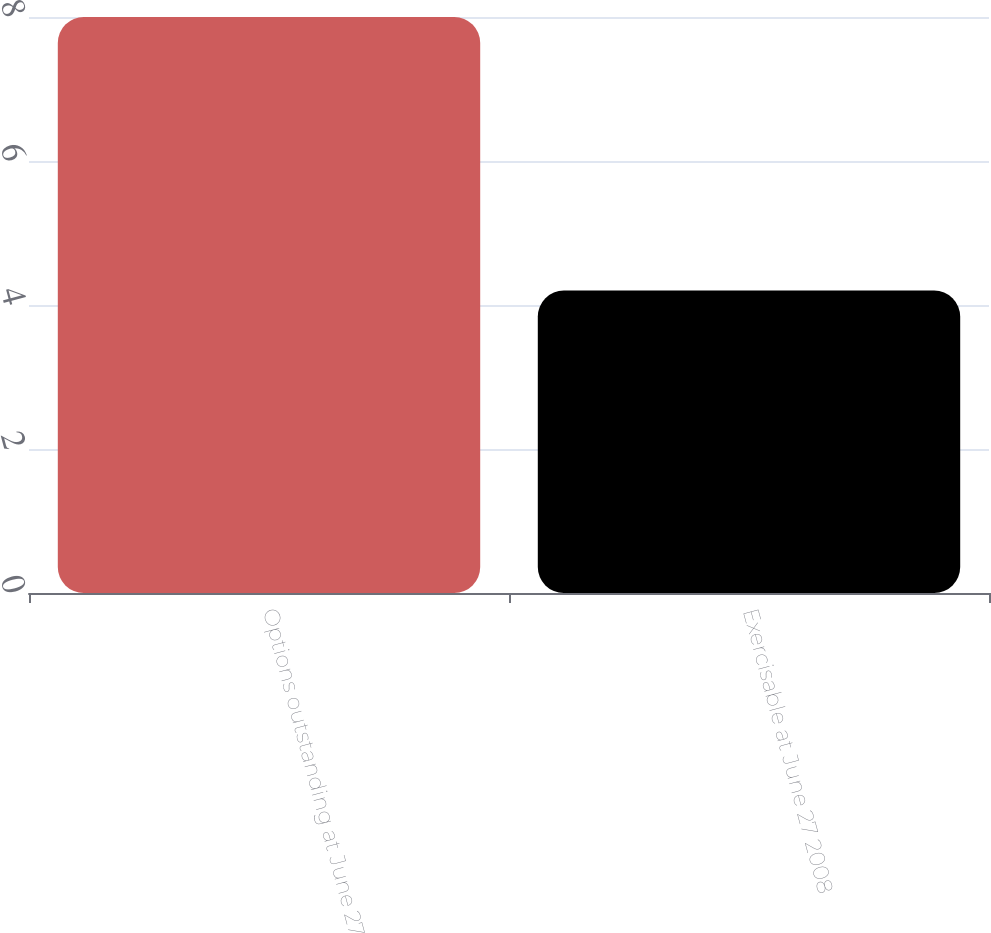Convert chart. <chart><loc_0><loc_0><loc_500><loc_500><bar_chart><fcel>Options outstanding at June 27<fcel>Exercisable at June 27 2008<nl><fcel>8<fcel>4.2<nl></chart> 